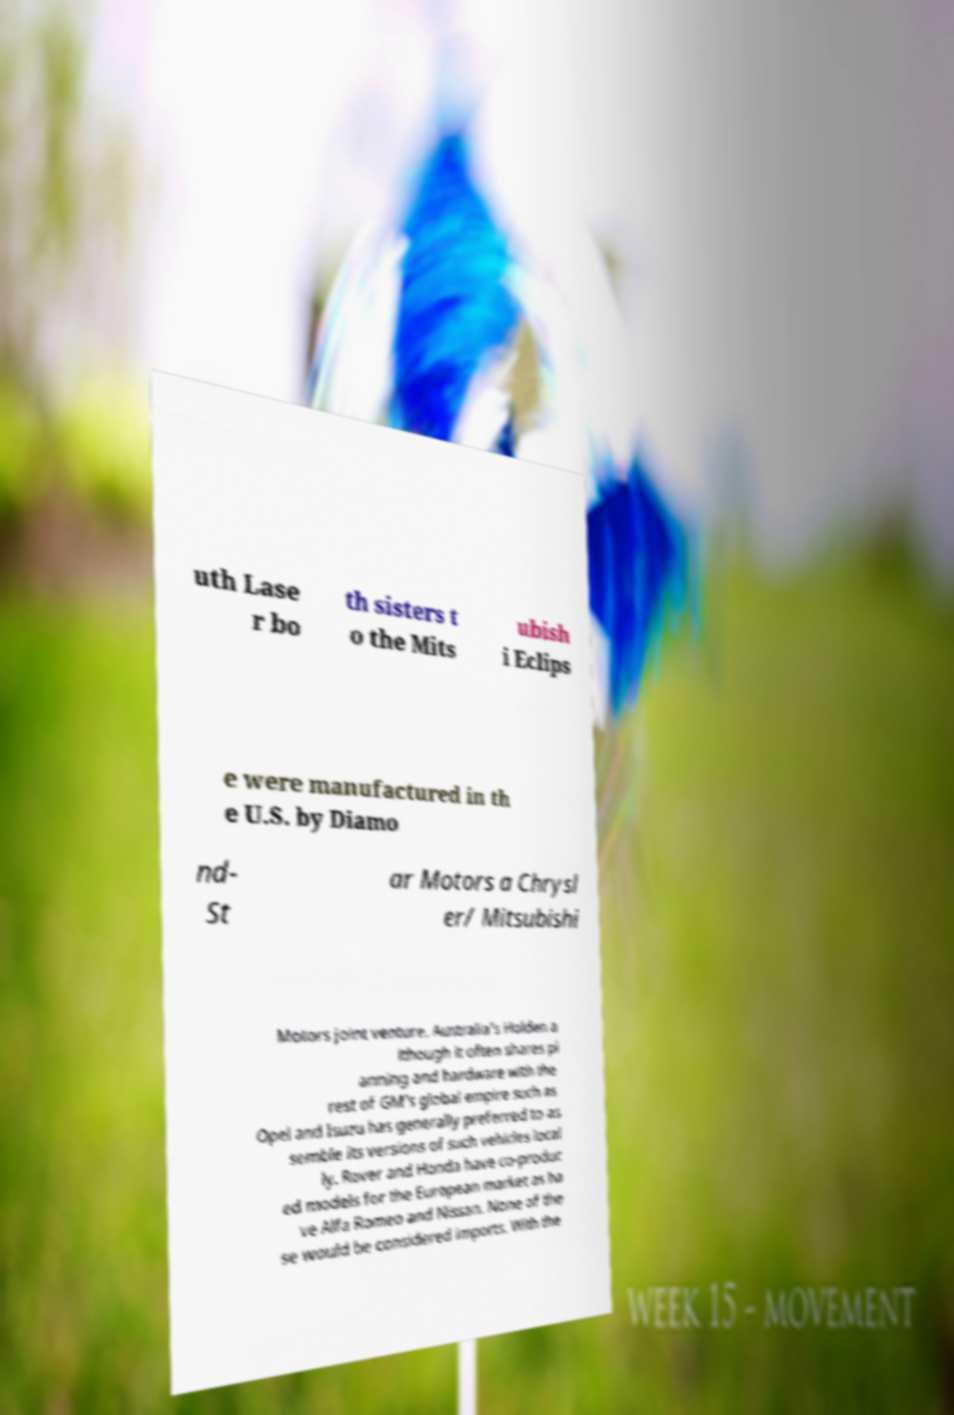For documentation purposes, I need the text within this image transcribed. Could you provide that? uth Lase r bo th sisters t o the Mits ubish i Eclips e were manufactured in th e U.S. by Diamo nd- St ar Motors a Chrysl er/ Mitsubishi Motors joint venture. Australia's Holden a lthough it often shares pl anning and hardware with the rest of GM's global empire such as Opel and Isuzu has generally preferred to as semble its versions of such vehicles local ly. Rover and Honda have co-produc ed models for the European market as ha ve Alfa Romeo and Nissan. None of the se would be considered imports. With the 